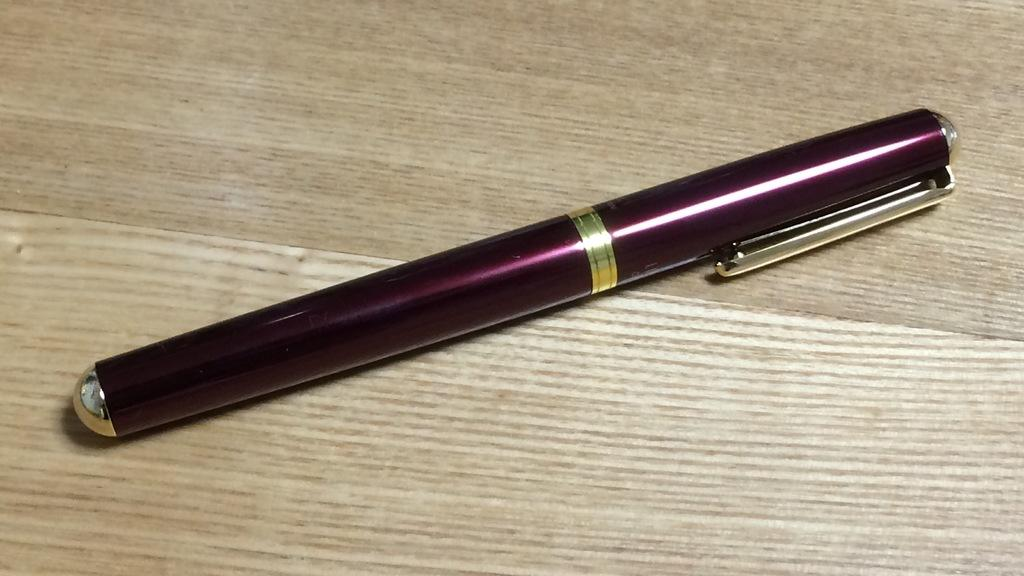What object is present in the image? There is a pen in the image. What type of surface is the pen resting on? The pen is on a wooden surface. Can you see a monkey washing the pen in the image? No, there is no monkey or washing activity present in the image. 